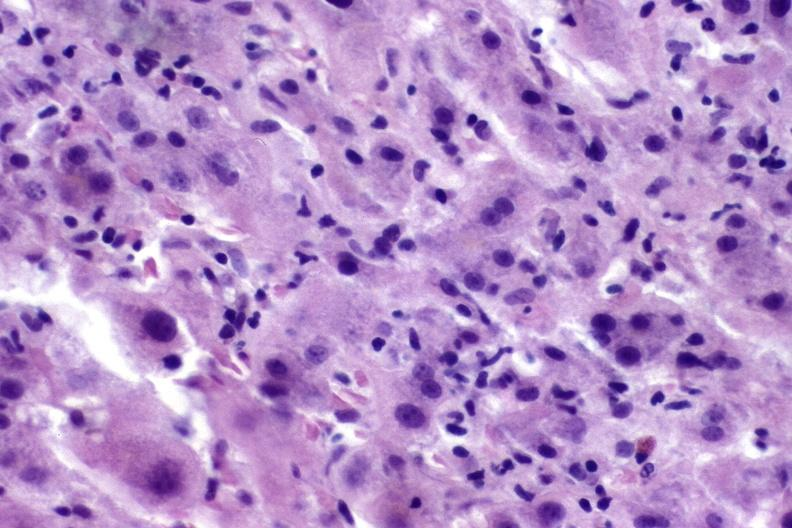s hepatobiliary present?
Answer the question using a single word or phrase. Yes 